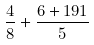<formula> <loc_0><loc_0><loc_500><loc_500>\frac { 4 } { 8 } + \frac { 6 + 1 9 1 } { 5 }</formula> 